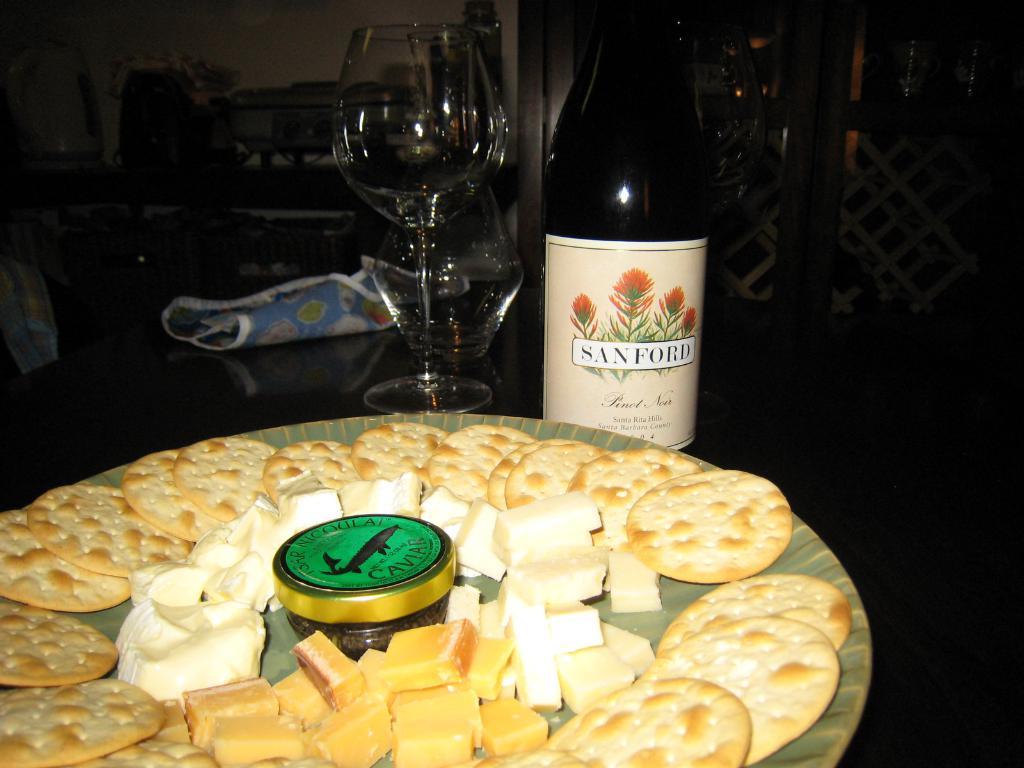What kind of wine is being served?
Make the answer very short. Sanford. 